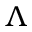<formula> <loc_0><loc_0><loc_500><loc_500>\Lambda</formula> 